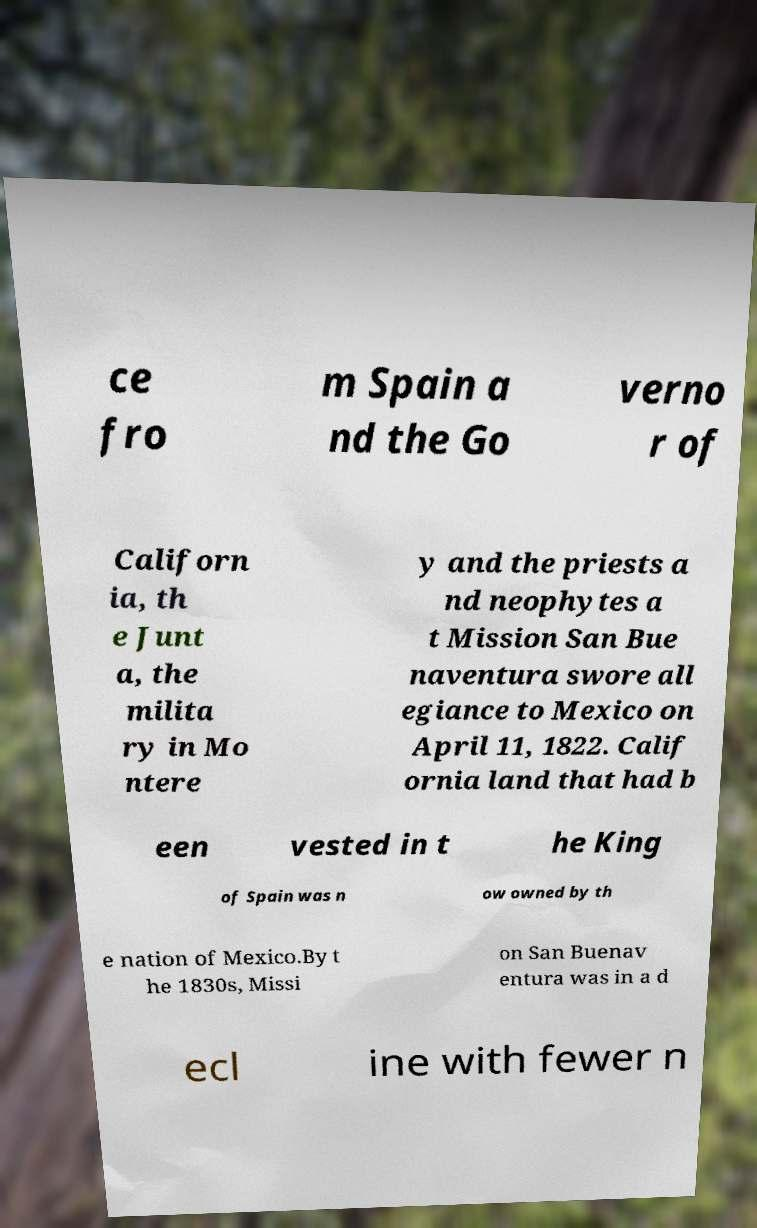Please identify and transcribe the text found in this image. ce fro m Spain a nd the Go verno r of Californ ia, th e Junt a, the milita ry in Mo ntere y and the priests a nd neophytes a t Mission San Bue naventura swore all egiance to Mexico on April 11, 1822. Calif ornia land that had b een vested in t he King of Spain was n ow owned by th e nation of Mexico.By t he 1830s, Missi on San Buenav entura was in a d ecl ine with fewer n 